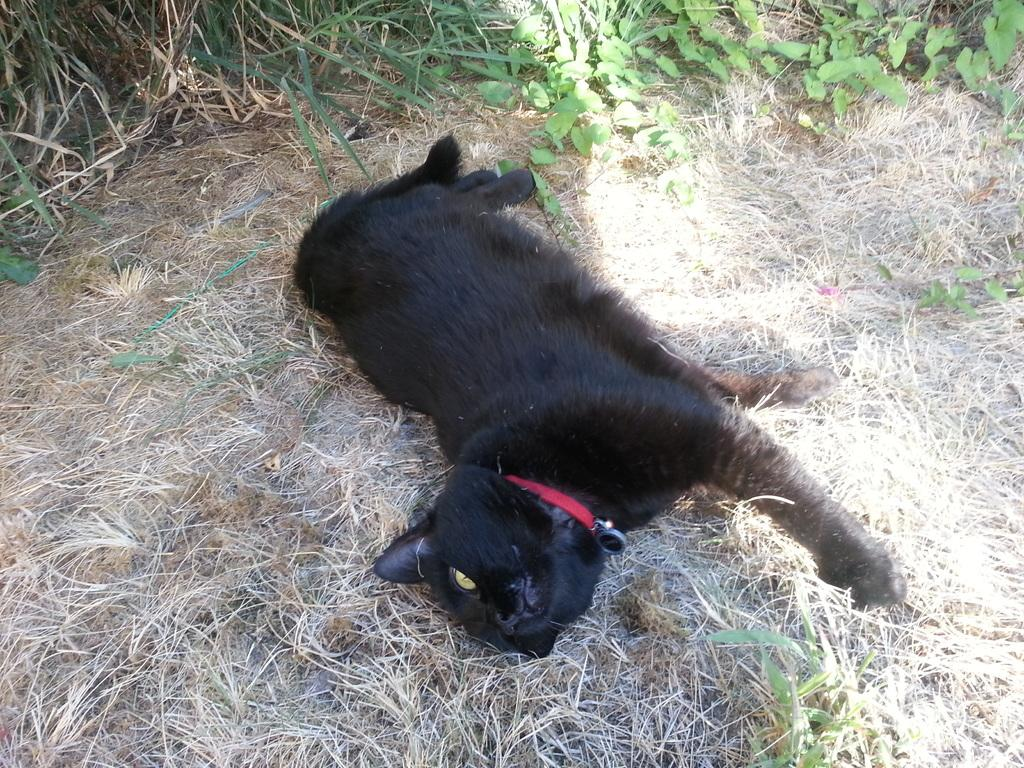What animal is in the foreground of the image? There is a black cat in the foreground of the image. What is the cat doing in the image? The cat is lying on the grass. What type of vegetation can be seen in the image? There is greenery visible at the top of the image. How many boys are sitting on the cat in the image? There are no boys present in the image, and the cat is lying on the grass, not being sat on by anyone. 